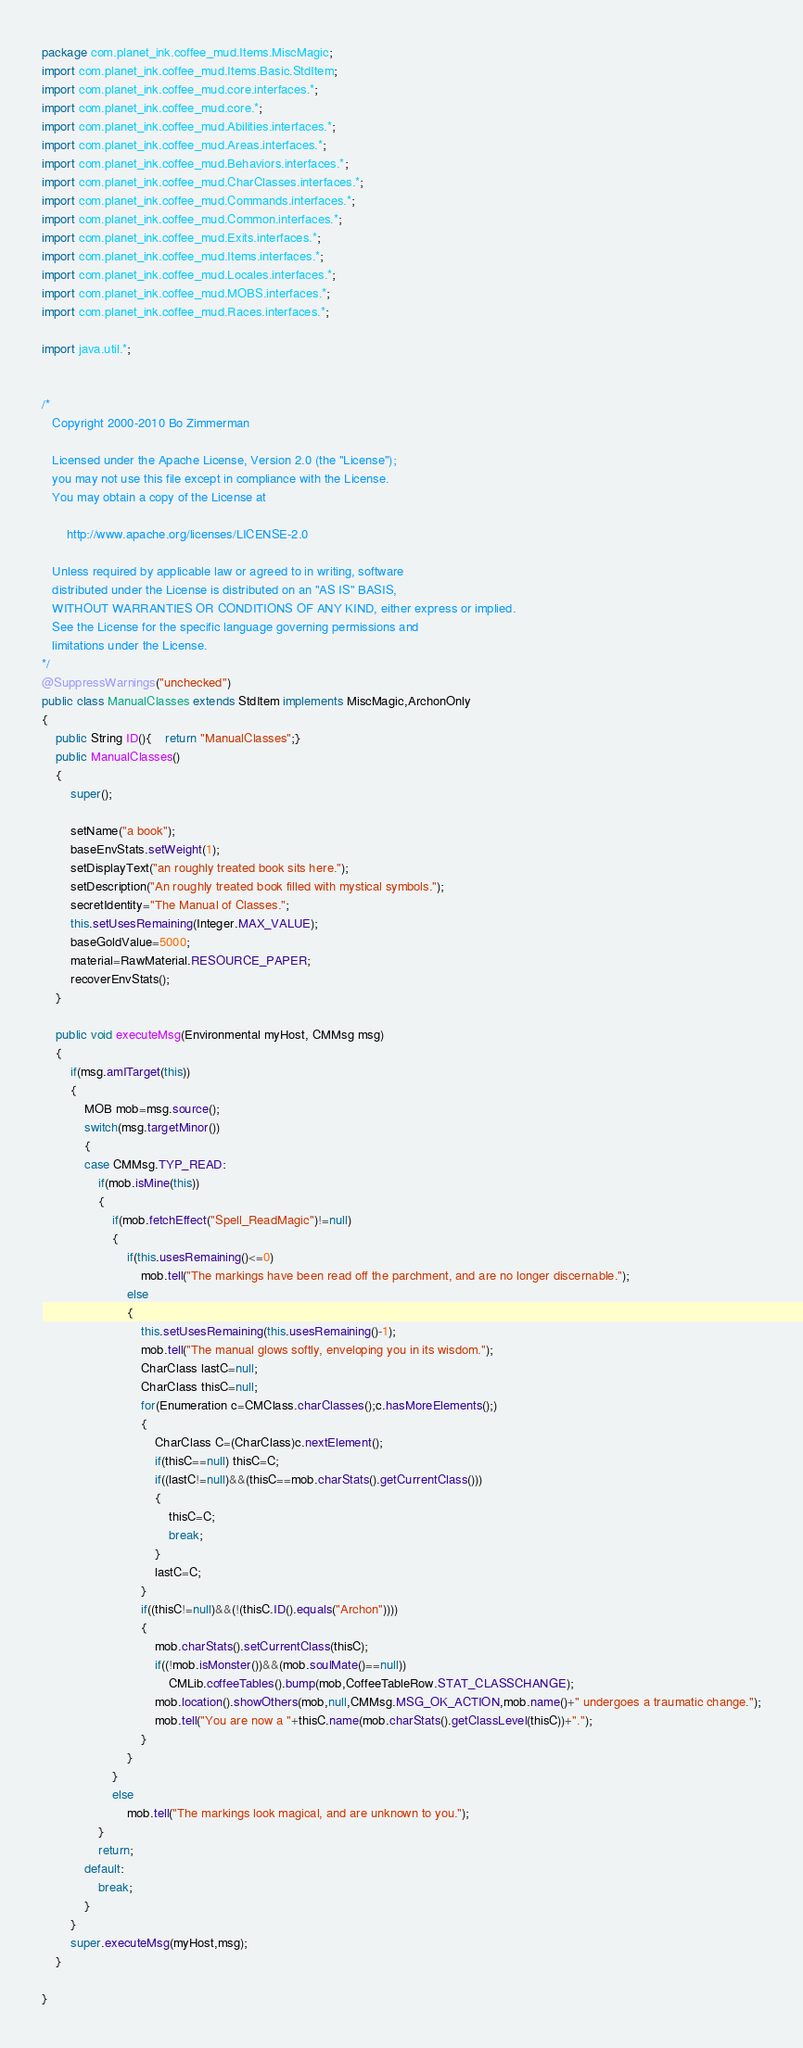<code> <loc_0><loc_0><loc_500><loc_500><_Java_>package com.planet_ink.coffee_mud.Items.MiscMagic;
import com.planet_ink.coffee_mud.Items.Basic.StdItem;
import com.planet_ink.coffee_mud.core.interfaces.*;
import com.planet_ink.coffee_mud.core.*;
import com.planet_ink.coffee_mud.Abilities.interfaces.*;
import com.planet_ink.coffee_mud.Areas.interfaces.*;
import com.planet_ink.coffee_mud.Behaviors.interfaces.*;
import com.planet_ink.coffee_mud.CharClasses.interfaces.*;
import com.planet_ink.coffee_mud.Commands.interfaces.*;
import com.planet_ink.coffee_mud.Common.interfaces.*;
import com.planet_ink.coffee_mud.Exits.interfaces.*;
import com.planet_ink.coffee_mud.Items.interfaces.*;
import com.planet_ink.coffee_mud.Locales.interfaces.*;
import com.planet_ink.coffee_mud.MOBS.interfaces.*;
import com.planet_ink.coffee_mud.Races.interfaces.*;

import java.util.*;


/* 
   Copyright 2000-2010 Bo Zimmerman

   Licensed under the Apache License, Version 2.0 (the "License");
   you may not use this file except in compliance with the License.
   You may obtain a copy of the License at

       http://www.apache.org/licenses/LICENSE-2.0

   Unless required by applicable law or agreed to in writing, software
   distributed under the License is distributed on an "AS IS" BASIS,
   WITHOUT WARRANTIES OR CONDITIONS OF ANY KIND, either express or implied.
   See the License for the specific language governing permissions and
   limitations under the License.
*/
@SuppressWarnings("unchecked")
public class ManualClasses extends StdItem implements MiscMagic,ArchonOnly
{
	public String ID(){	return "ManualClasses";}
	public ManualClasses()
	{
		super();

		setName("a book");
		baseEnvStats.setWeight(1);
		setDisplayText("an roughly treated book sits here.");
		setDescription("An roughly treated book filled with mystical symbols.");
		secretIdentity="The Manual of Classes.";
		this.setUsesRemaining(Integer.MAX_VALUE);
		baseGoldValue=5000;
		material=RawMaterial.RESOURCE_PAPER;
		recoverEnvStats();
	}

	public void executeMsg(Environmental myHost, CMMsg msg)
	{
		if(msg.amITarget(this))
		{
			MOB mob=msg.source();
			switch(msg.targetMinor())
			{
			case CMMsg.TYP_READ:
				if(mob.isMine(this))
				{
					if(mob.fetchEffect("Spell_ReadMagic")!=null)
					{
						if(this.usesRemaining()<=0)
							mob.tell("The markings have been read off the parchment, and are no longer discernable.");
						else
						{
							this.setUsesRemaining(this.usesRemaining()-1);
							mob.tell("The manual glows softly, enveloping you in its wisdom.");
							CharClass lastC=null;
							CharClass thisC=null;
							for(Enumeration c=CMClass.charClasses();c.hasMoreElements();)
							{
								CharClass C=(CharClass)c.nextElement();
								if(thisC==null) thisC=C;
								if((lastC!=null)&&(thisC==mob.charStats().getCurrentClass()))
								{
									thisC=C;
									break;
								}
								lastC=C;
							}
							if((thisC!=null)&&(!(thisC.ID().equals("Archon"))))
							{
								mob.charStats().setCurrentClass(thisC);
								if((!mob.isMonster())&&(mob.soulMate()==null))
									CMLib.coffeeTables().bump(mob,CoffeeTableRow.STAT_CLASSCHANGE);
								mob.location().showOthers(mob,null,CMMsg.MSG_OK_ACTION,mob.name()+" undergoes a traumatic change.");
                                mob.tell("You are now a "+thisC.name(mob.charStats().getClassLevel(thisC))+".");
							}
						}
					}
					else
						mob.tell("The markings look magical, and are unknown to you.");
				}
				return;
			default:
				break;
			}
		}
		super.executeMsg(myHost,msg);
	}

}
</code> 